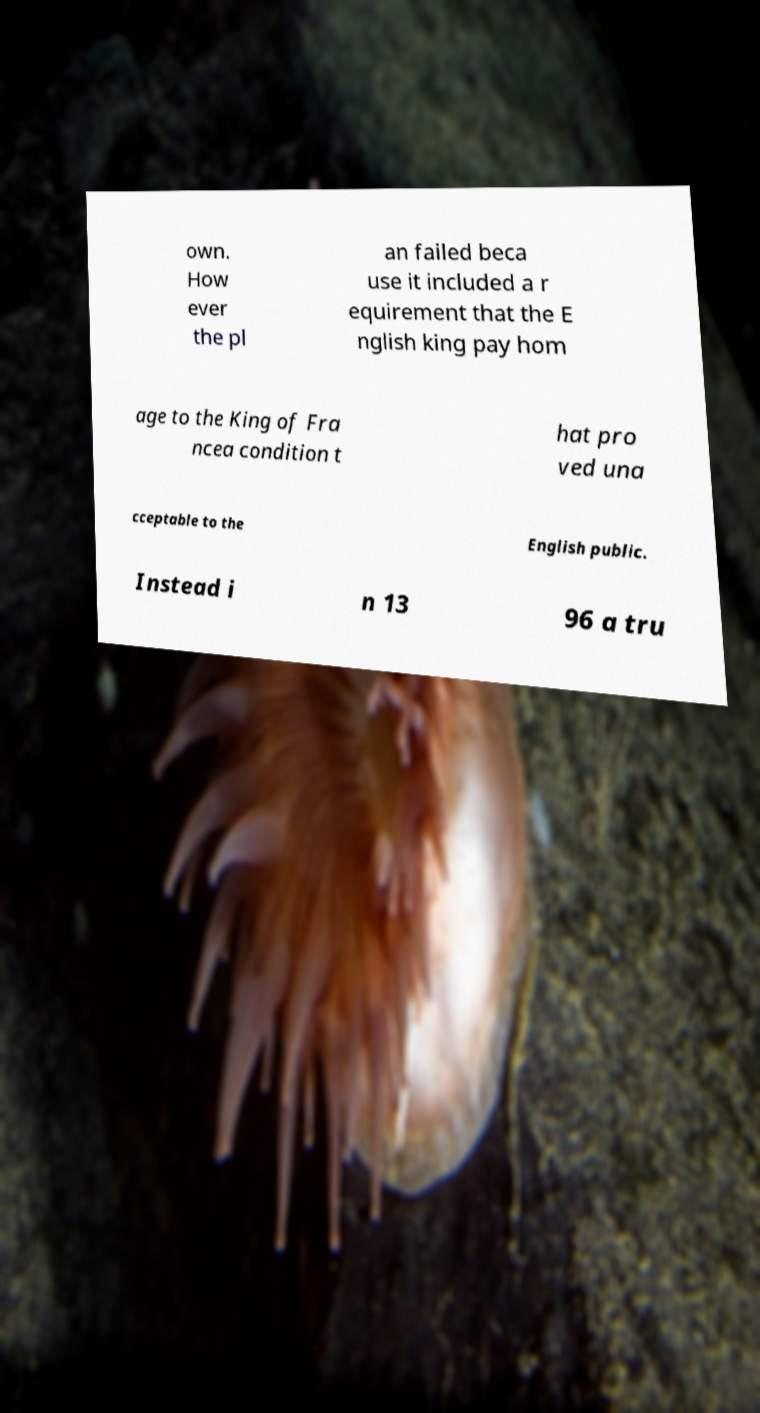Could you assist in decoding the text presented in this image and type it out clearly? own. How ever the pl an failed beca use it included a r equirement that the E nglish king pay hom age to the King of Fra ncea condition t hat pro ved una cceptable to the English public. Instead i n 13 96 a tru 